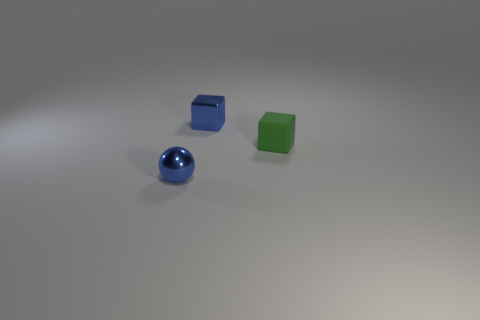Add 3 small purple cylinders. How many objects exist? 6 Subtract all cubes. How many objects are left? 1 Subtract all blue metallic objects. Subtract all blue spheres. How many objects are left? 0 Add 2 green matte objects. How many green matte objects are left? 3 Add 3 blue shiny blocks. How many blue shiny blocks exist? 4 Subtract 0 cyan cylinders. How many objects are left? 3 